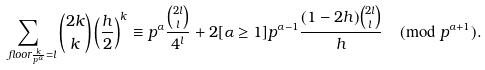<formula> <loc_0><loc_0><loc_500><loc_500>\sum _ { \ f l o o r { \frac { k } { p ^ { \alpha } } } = l } \binom { 2 k } { k } \left ( \frac { h } { 2 } \right ) ^ { k } \equiv p ^ { \alpha } \frac { \binom { 2 l } { l } } { 4 ^ { l } } + 2 [ { \alpha } \geq 1 ] p ^ { { \alpha } - 1 } \frac { ( 1 - 2 h ) \binom { 2 l } { l } } { h } \pmod { p ^ { { \alpha } + 1 } } .</formula> 